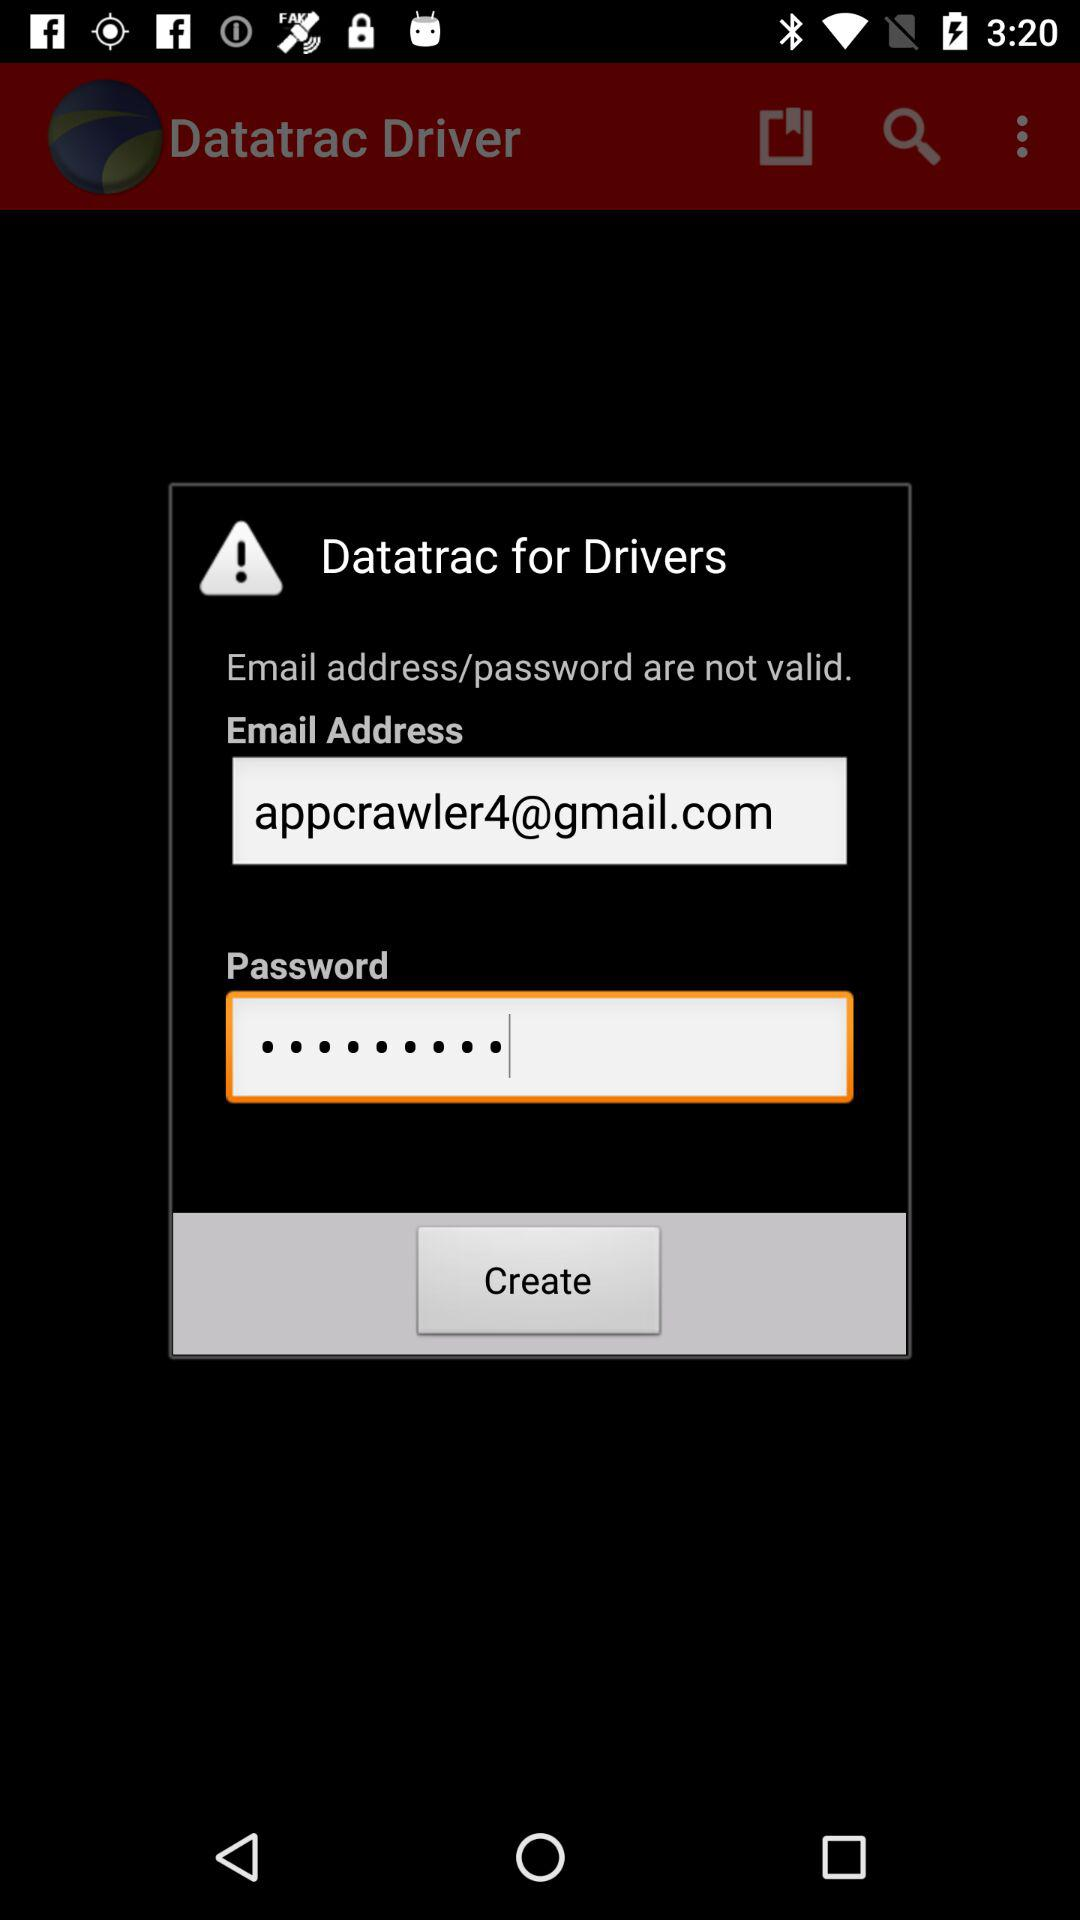What is the email address? The email address is appcrawler4@gmail.com. 